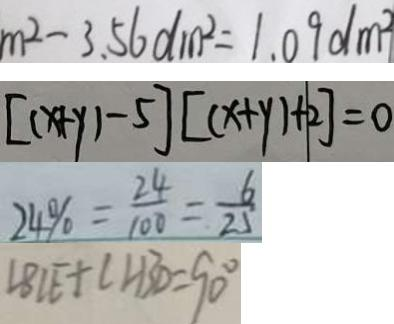Convert formula to latex. <formula><loc_0><loc_0><loc_500><loc_500>m ^ { 2 } - 3 . 5 6 d m ^ { 2 } = 1 . 0 9 d m ^ { 2 } 
 [ ( x + y ) - 5 ] [ ( x + y ) + 2 ] = 0 
 2 4 \% = \frac { 2 4 } { 1 0 0 } = \frac { 6 } { 2 5 } 
 \angle B C E + \angle A B D = 9 0 ^ { \circ }</formula> 